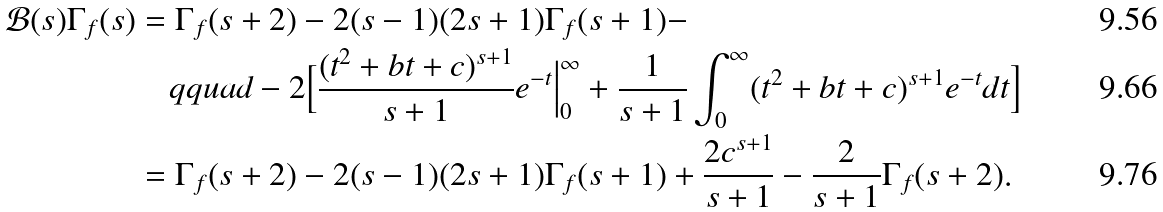<formula> <loc_0><loc_0><loc_500><loc_500>\mathcal { B } ( s ) \Gamma _ { f } ( s ) & = \Gamma _ { f } ( s + 2 ) - 2 ( s - 1 ) ( 2 s + 1 ) \Gamma _ { f } ( s + 1 ) - \\ & \quad q q u a d - 2 \Big [ \frac { ( t ^ { 2 } + b t + c ) ^ { s + 1 } } { s + 1 } e ^ { - t } \Big | _ { 0 } ^ { \infty } + \frac { 1 } { s + 1 } \int _ { 0 } ^ { \infty } ( t ^ { 2 } + b t + c ) ^ { s + 1 } e ^ { - t } d t \Big ] \\ & = \Gamma _ { f } ( s + 2 ) - 2 ( s - 1 ) ( 2 s + 1 ) \Gamma _ { f } ( s + 1 ) + \frac { 2 c ^ { s + 1 } } { s + 1 } - \frac { 2 } { s + 1 } \Gamma _ { f } ( s + 2 ) .</formula> 